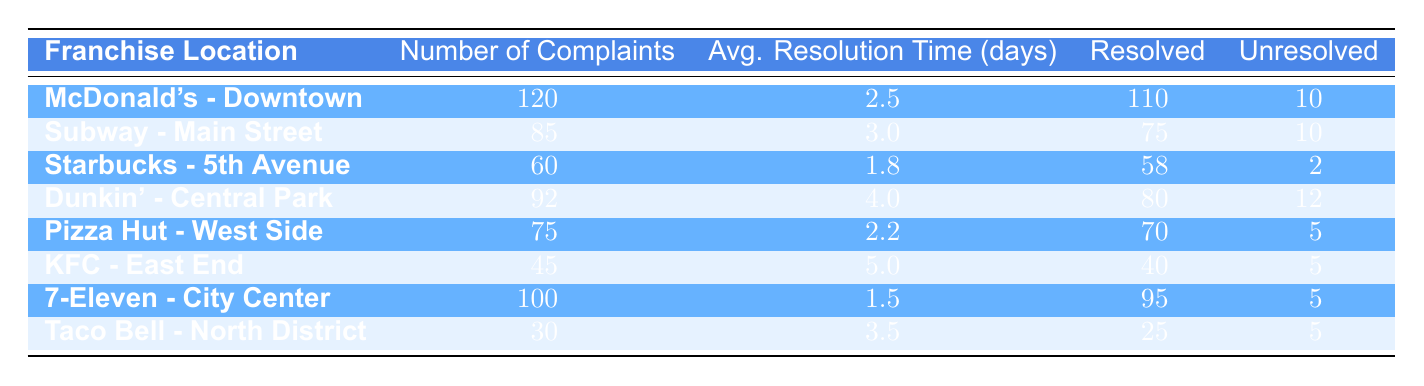What is the average resolution time for customer complaints at Starbucks - 5th Avenue? The resolution time for Starbucks - 5th Avenue is listed in the table as 1.8 days.
Answer: 1.8 days Which franchise location had the highest number of unresolved complaints? By examining the unresolved complaints column, Dunkin' - Central Park and Subway - Main Street both have 10 unresolved complaints. However, Dunkin' resolved 80 complaints compared to Subway's 75, resulting in a higher number of total complaints at Dunkin'.
Answer: Dunkin' - Central Park How many complaints in total were resolved across all franchise locations? The resolved complaints from each franchise are: McDonald's (110), Subway (75), Starbucks (58), Dunkin' (80), Pizza Hut (70), KFC (40), 7-Eleven (95), and Taco Bell (25). Adding these gives: 110 + 75 + 58 + 80 + 70 + 40 + 95 + 25 = 513.
Answer: 513 Is there any franchise location with an average resolution time less than 2 days? Upon checking the average resolution times, 7-Eleven - City Center has an average resolution time of 1.5 days, which is less than 2 days.
Answer: Yes What is the average resolution time for the top three franchises by number of complaints? The top three franchises by number of complaints are McDonald's (2.5 days), Dunkin' (4.0 days), and Subway (3.0 days). To find the average, sum these times: 2.5 + 4.0 + 3.0 = 9.5, then divide by 3 to get an average of 9.5 / 3 = 3.17 days.
Answer: 3.17 days 